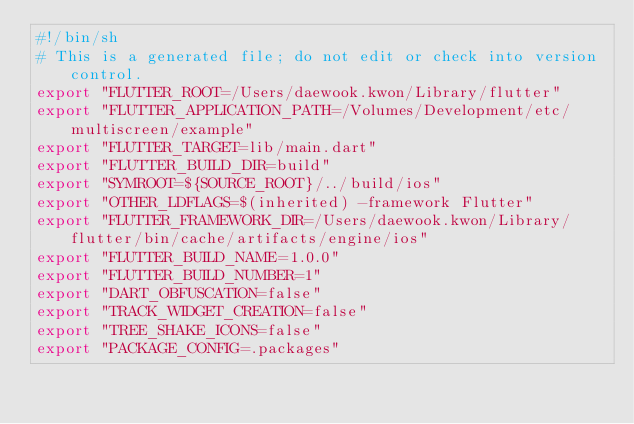<code> <loc_0><loc_0><loc_500><loc_500><_Bash_>#!/bin/sh
# This is a generated file; do not edit or check into version control.
export "FLUTTER_ROOT=/Users/daewook.kwon/Library/flutter"
export "FLUTTER_APPLICATION_PATH=/Volumes/Development/etc/multiscreen/example"
export "FLUTTER_TARGET=lib/main.dart"
export "FLUTTER_BUILD_DIR=build"
export "SYMROOT=${SOURCE_ROOT}/../build/ios"
export "OTHER_LDFLAGS=$(inherited) -framework Flutter"
export "FLUTTER_FRAMEWORK_DIR=/Users/daewook.kwon/Library/flutter/bin/cache/artifacts/engine/ios"
export "FLUTTER_BUILD_NAME=1.0.0"
export "FLUTTER_BUILD_NUMBER=1"
export "DART_OBFUSCATION=false"
export "TRACK_WIDGET_CREATION=false"
export "TREE_SHAKE_ICONS=false"
export "PACKAGE_CONFIG=.packages"
</code> 